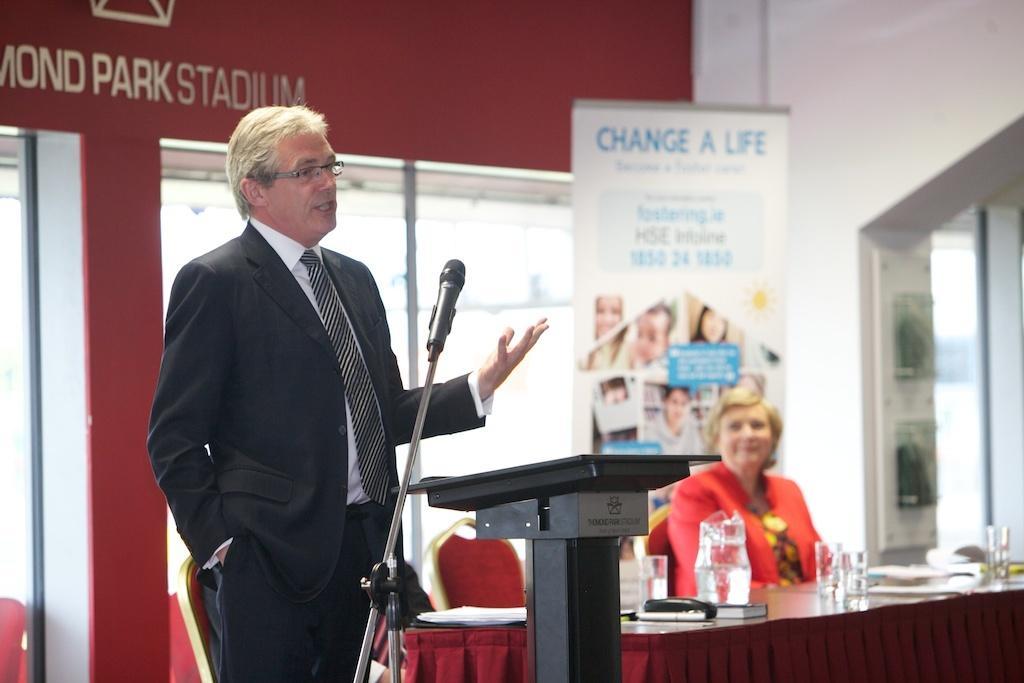Please provide a concise description of this image. This image consists of a man wearing black suit is standing in front of the mic. In the background, there is a wall in red color. To the right, there is a woman sitting in a chair near the table. 